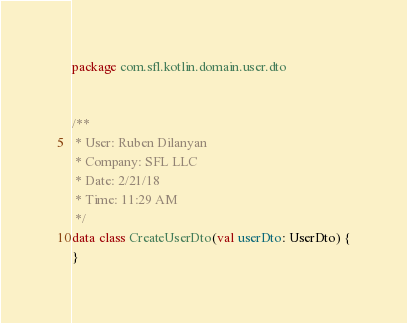<code> <loc_0><loc_0><loc_500><loc_500><_Kotlin_>package com.sfl.kotlin.domain.user.dto


/**
 * User: Ruben Dilanyan
 * Company: SFL LLC
 * Date: 2/21/18
 * Time: 11:29 AM
 */
data class CreateUserDto(val userDto: UserDto) {
}</code> 